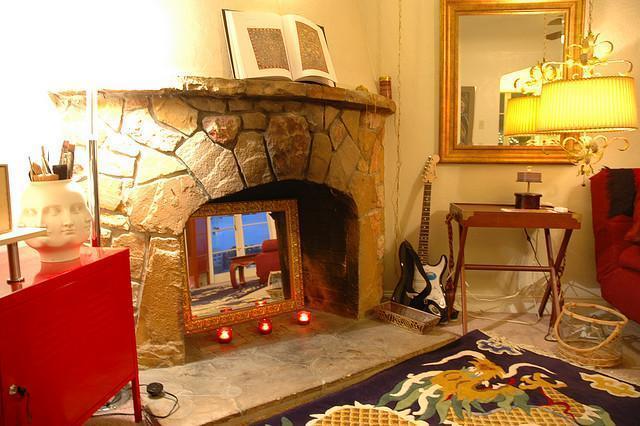How many vases are in the picture?
Give a very brief answer. 1. How many books are there?
Give a very brief answer. 1. How many people could sleep in the bed?
Give a very brief answer. 0. 